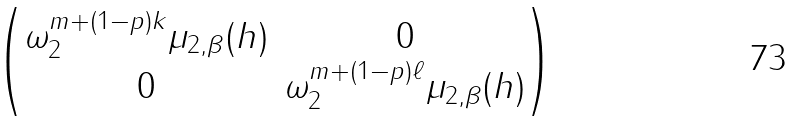Convert formula to latex. <formula><loc_0><loc_0><loc_500><loc_500>\begin{pmatrix} \omega _ { 2 } ^ { m + ( 1 - p ) k } \mu _ { 2 , \beta } ( h ) & 0 \\ 0 & \omega _ { 2 } ^ { m + ( 1 - p ) \ell } \mu _ { 2 , \beta } ( h ) \end{pmatrix}</formula> 